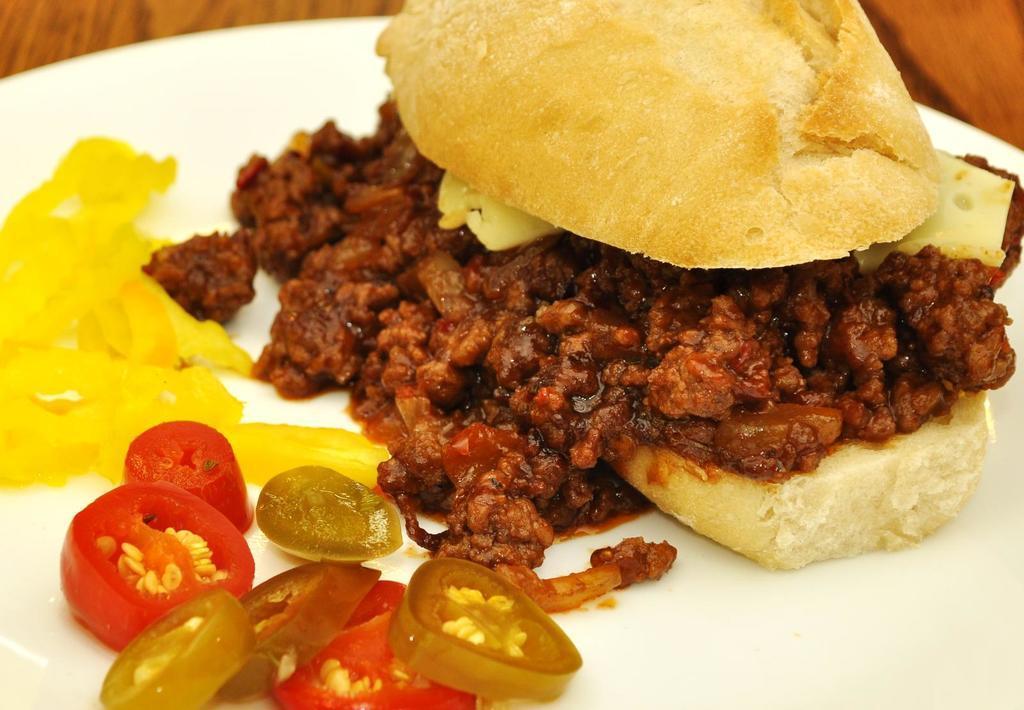Describe this image in one or two sentences. In this image I can see food which is in brown, red, yellow color in the plate and the plate is in white color. The plate is on the table, the table is in brown color. 